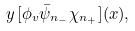<formula> <loc_0><loc_0><loc_500><loc_500>y \, [ \phi _ { v } \bar { \psi } _ { n _ { - } } \chi _ { n _ { + } } ] ( x ) ,</formula> 